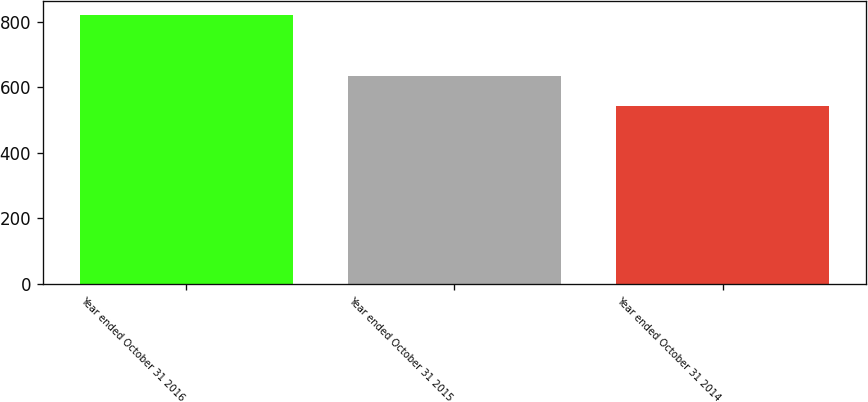<chart> <loc_0><loc_0><loc_500><loc_500><bar_chart><fcel>Year ended October 31 2016<fcel>Year ended October 31 2015<fcel>Year ended October 31 2014<nl><fcel>821<fcel>633<fcel>543<nl></chart> 